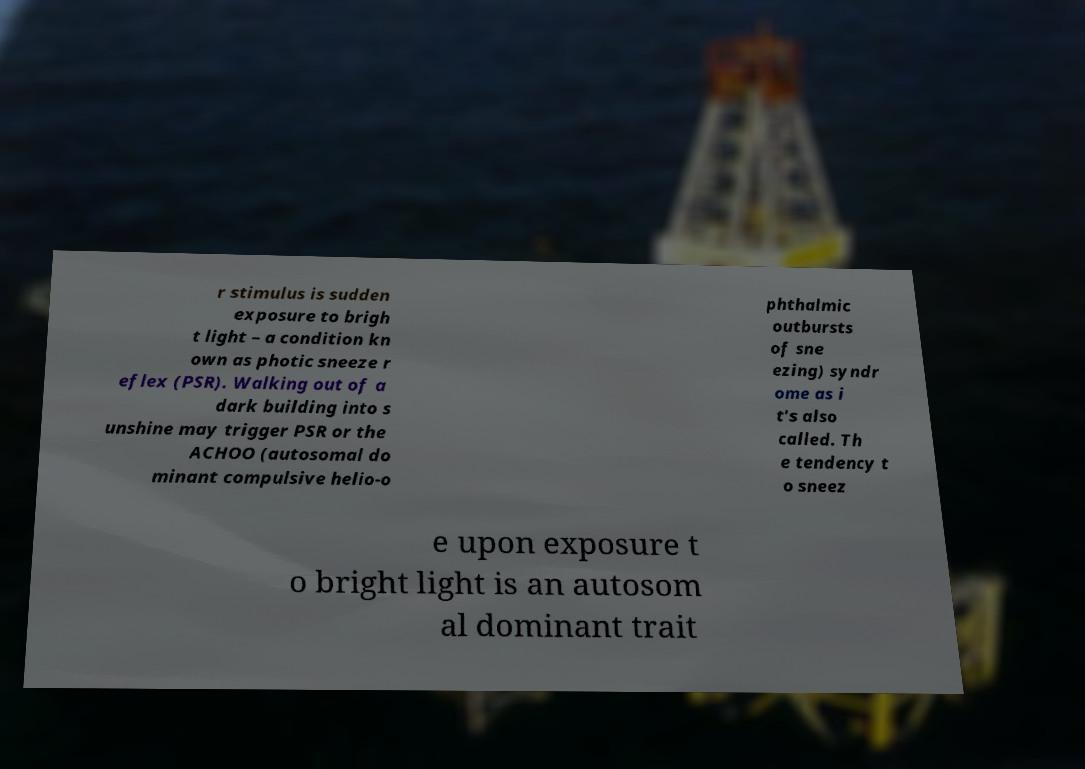Please read and relay the text visible in this image. What does it say? r stimulus is sudden exposure to brigh t light – a condition kn own as photic sneeze r eflex (PSR). Walking out of a dark building into s unshine may trigger PSR or the ACHOO (autosomal do minant compulsive helio-o phthalmic outbursts of sne ezing) syndr ome as i t's also called. Th e tendency t o sneez e upon exposure t o bright light is an autosom al dominant trait 